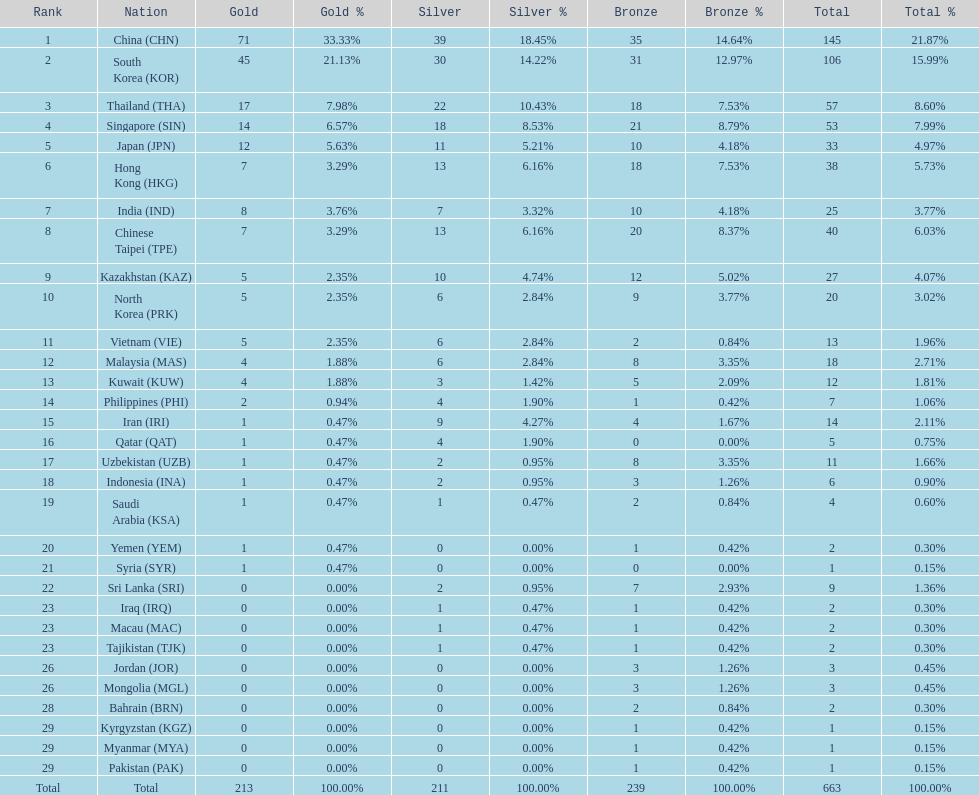Which countries have the same number of silver medals in the asian youth games as north korea? Vietnam (VIE), Malaysia (MAS). 